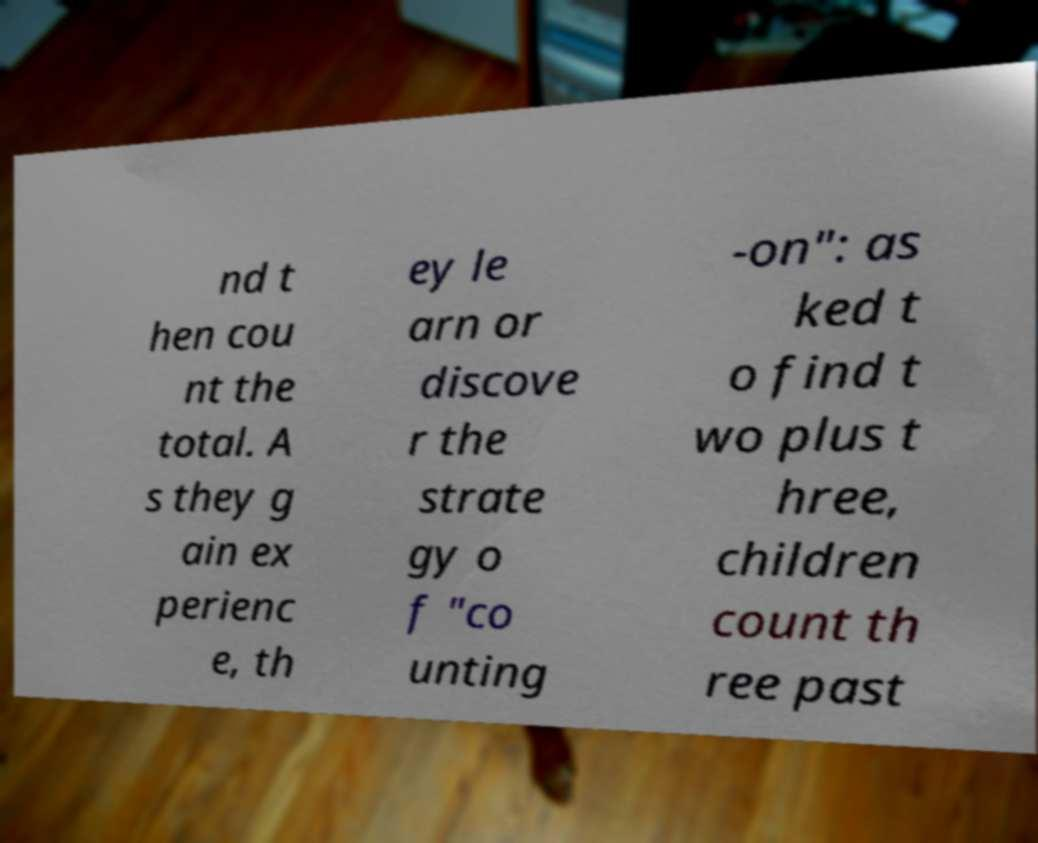What messages or text are displayed in this image? I need them in a readable, typed format. nd t hen cou nt the total. A s they g ain ex perienc e, th ey le arn or discove r the strate gy o f "co unting -on": as ked t o find t wo plus t hree, children count th ree past 